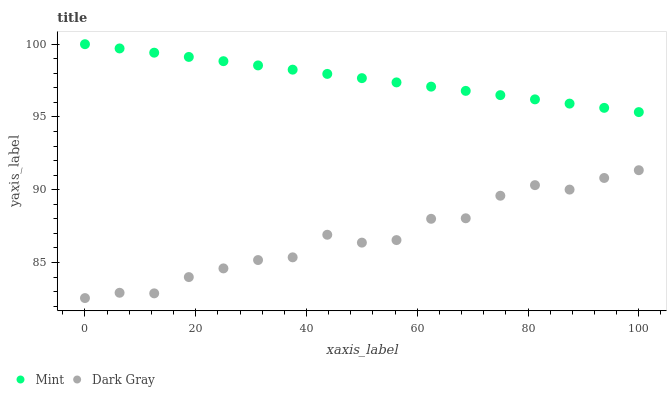Does Dark Gray have the minimum area under the curve?
Answer yes or no. Yes. Does Mint have the maximum area under the curve?
Answer yes or no. Yes. Does Mint have the minimum area under the curve?
Answer yes or no. No. Is Mint the smoothest?
Answer yes or no. Yes. Is Dark Gray the roughest?
Answer yes or no. Yes. Is Mint the roughest?
Answer yes or no. No. Does Dark Gray have the lowest value?
Answer yes or no. Yes. Does Mint have the lowest value?
Answer yes or no. No. Does Mint have the highest value?
Answer yes or no. Yes. Is Dark Gray less than Mint?
Answer yes or no. Yes. Is Mint greater than Dark Gray?
Answer yes or no. Yes. Does Dark Gray intersect Mint?
Answer yes or no. No. 